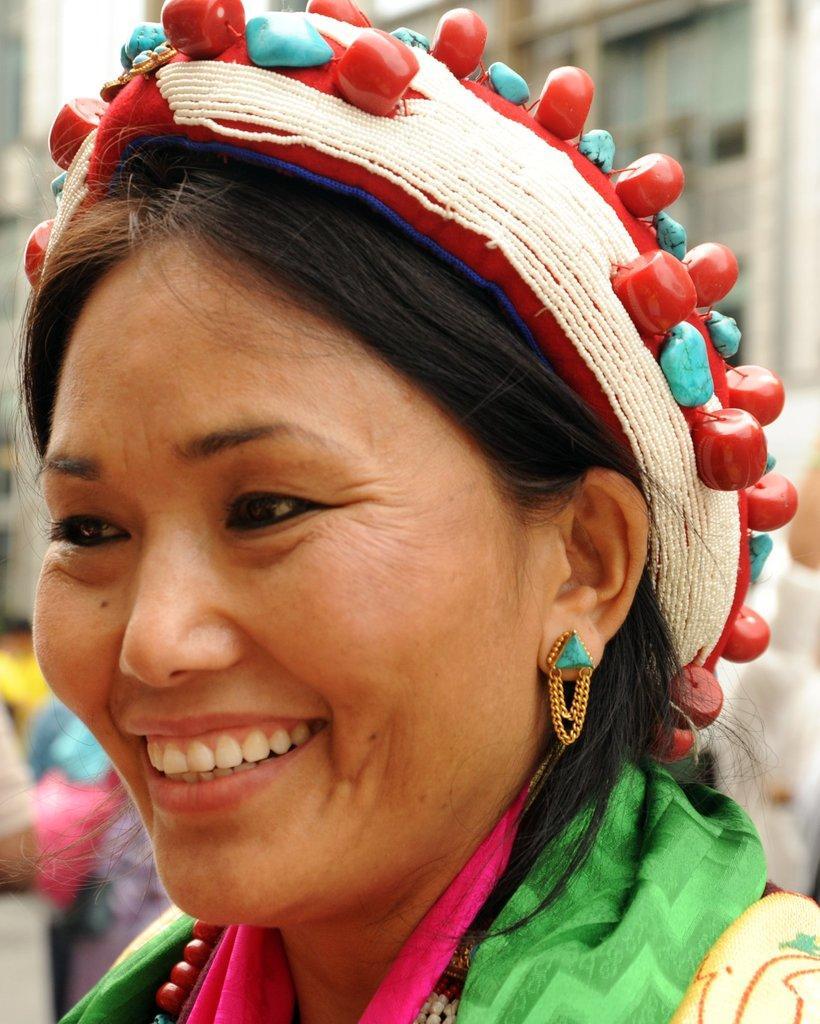In one or two sentences, can you explain what this image depicts? In this image we can see a person who has some cap on the head to which there are some beads. 